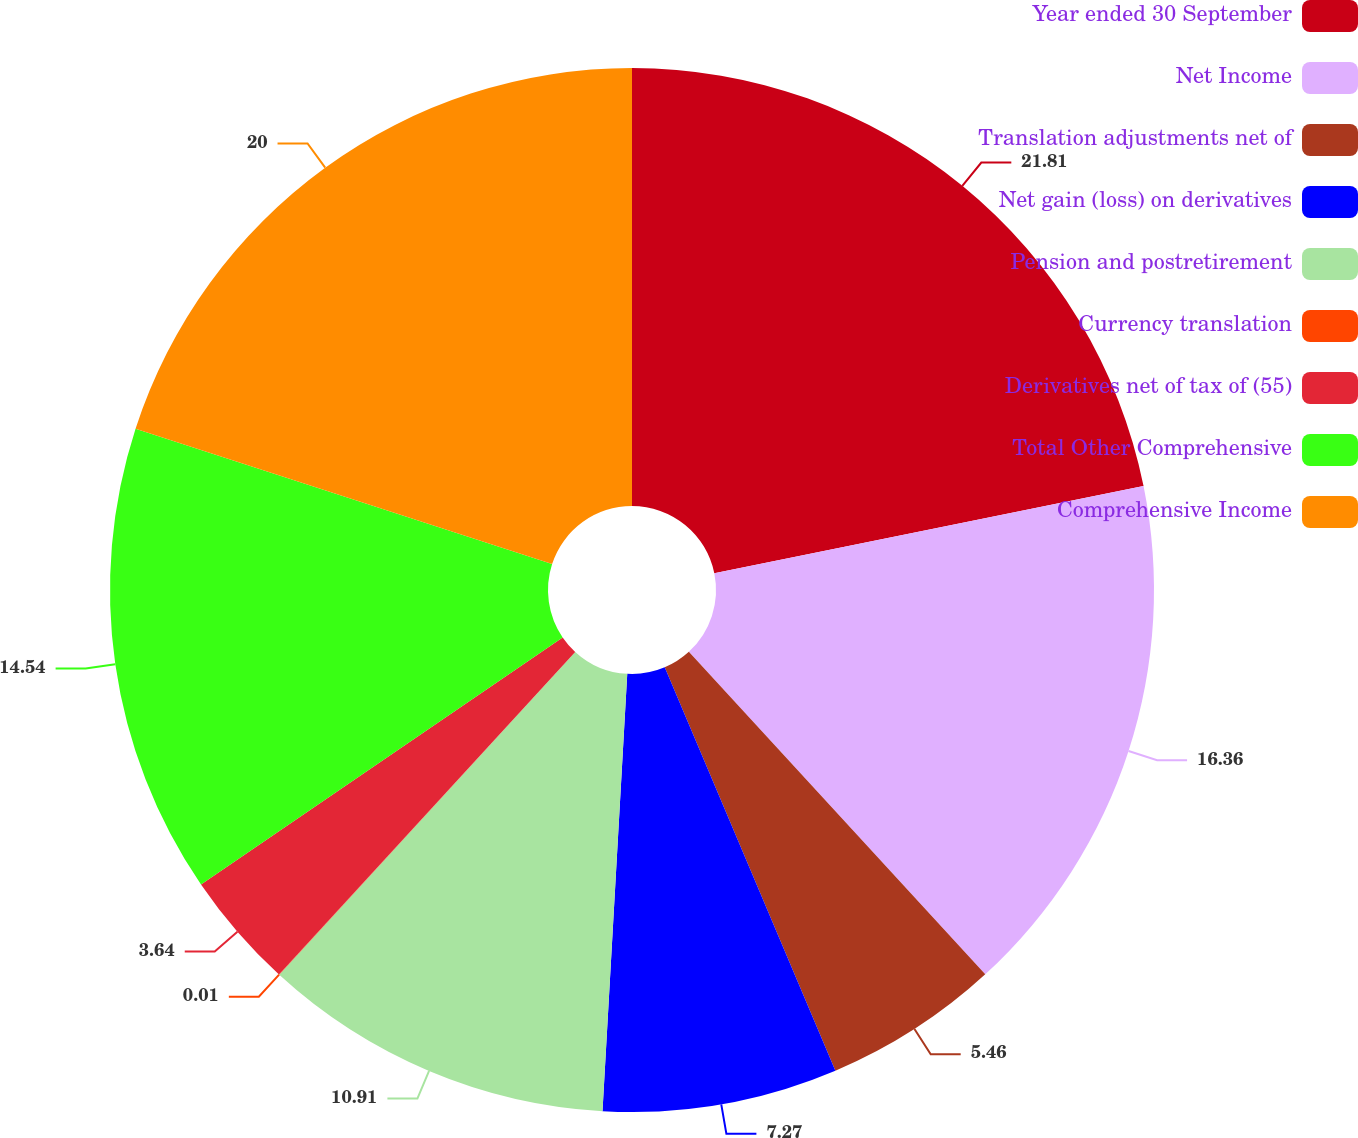Convert chart. <chart><loc_0><loc_0><loc_500><loc_500><pie_chart><fcel>Year ended 30 September<fcel>Net Income<fcel>Translation adjustments net of<fcel>Net gain (loss) on derivatives<fcel>Pension and postretirement<fcel>Currency translation<fcel>Derivatives net of tax of (55)<fcel>Total Other Comprehensive<fcel>Comprehensive Income<nl><fcel>21.81%<fcel>16.36%<fcel>5.46%<fcel>7.27%<fcel>10.91%<fcel>0.01%<fcel>3.64%<fcel>14.54%<fcel>20.0%<nl></chart> 